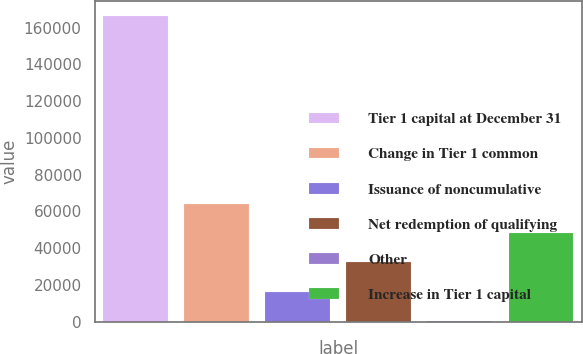Convert chart. <chart><loc_0><loc_0><loc_500><loc_500><bar_chart><fcel>Tier 1 capital at December 31<fcel>Change in Tier 1 common<fcel>Issuance of noncumulative<fcel>Net redemption of qualifying<fcel>Other<fcel>Increase in Tier 1 capital<nl><fcel>166354<fcel>64182.6<fcel>16272.9<fcel>32242.8<fcel>303<fcel>48212.7<nl></chart> 